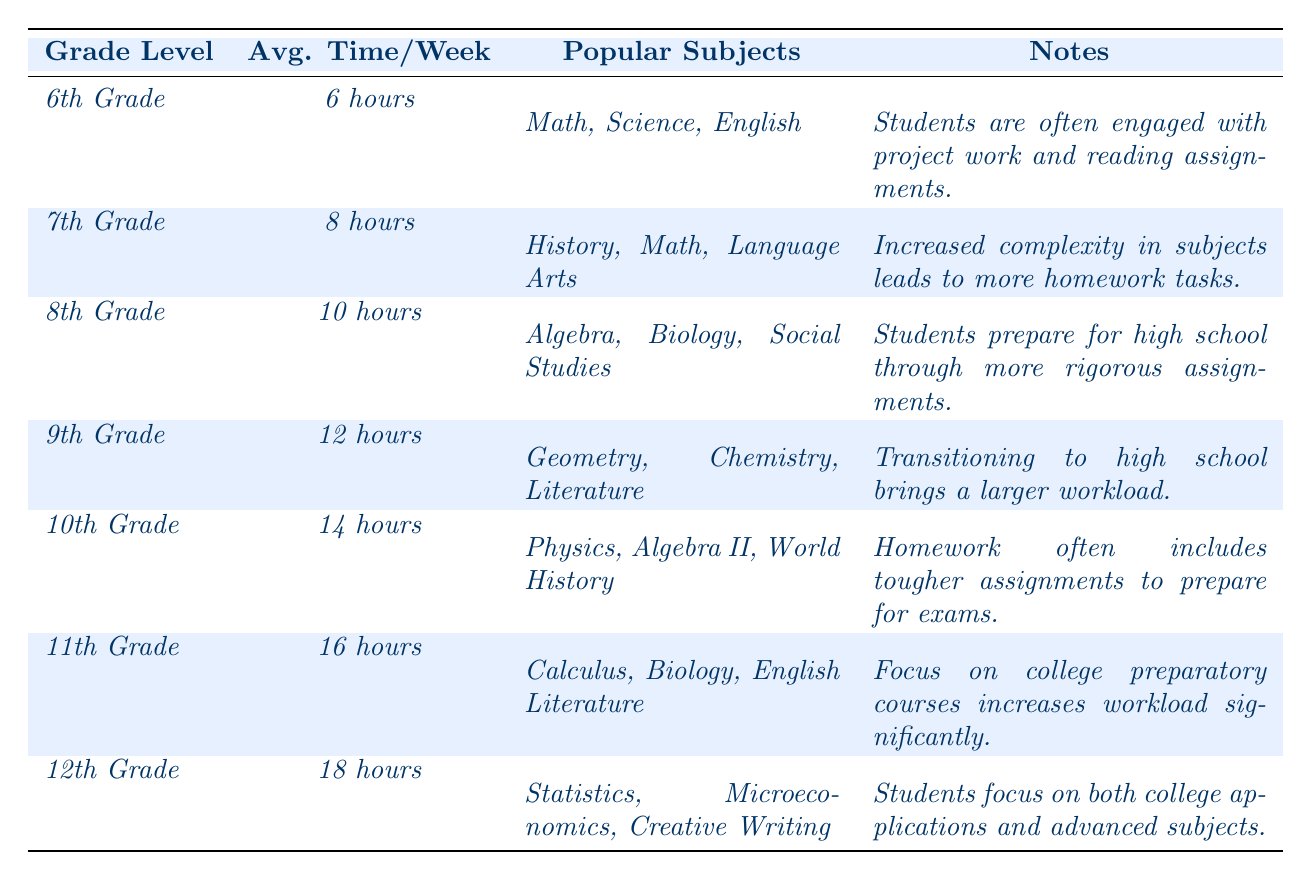What's the average time spent on homework by 12th graders? According to the table, 12th graders spend an average of 18 hours per week on homework.
Answer: 18 hours Which grade level has the highest average homework time? The table indicates that 12th Grade has the highest average time spent on homework, which is 18 hours per week.
Answer: 12th Grade What are the popular subjects for 10th graders? For 10th Grade, the popular subjects listed in the table are Physics, Algebra II, and World History.
Answer: Physics, Algebra II, World History Do students in 8th Grade spend more time on homework than those in 6th Grade? Yes, 8th graders spend 10 hours per week, while 6th graders spend only 6 hours, indicating that 8th graders spend more time.
Answer: Yes What is the difference in average homework time between 9th and 10th graders? 9th graders spend 12 hours and 10th graders spend 14 hours per week. The difference is 14 - 12 = 2 hours.
Answer: 2 hours Which grade level focuses more on college preparatory courses? According to the table, 11th Grade focuses on college preparatory courses, which increases their workload significantly.
Answer: 11th Grade How much total average homework time do students in 11th and 12th grades spend combined? 11th graders spend 16 hours and 12th graders spend 18 hours. Adding these gives 16 + 18 = 34 hours total for both grades.
Answer: 34 hours Are "Math" and "Science" popular subjects in the same grade level? Yes, "Math" is popular in 6th Grade, while "Science" is also popular in the same grade level, indicating they are both popular subjects for 6th graders.
Answer: Yes Identify the grade level with the most rigorous assignments based on average homework time. 12th Grade has the highest average time spent on homework (18 hours), indicating the most rigorous assignments among peers.
Answer: 12th Grade How many hours per week do 7th graders spend on homework compared to 11th graders? 7th graders spend 8 hours, while 11th graders spend 16 hours. Thus, 11th graders spend 16 - 8 = 8 hours more than 7th graders.
Answer: 8 hours more 